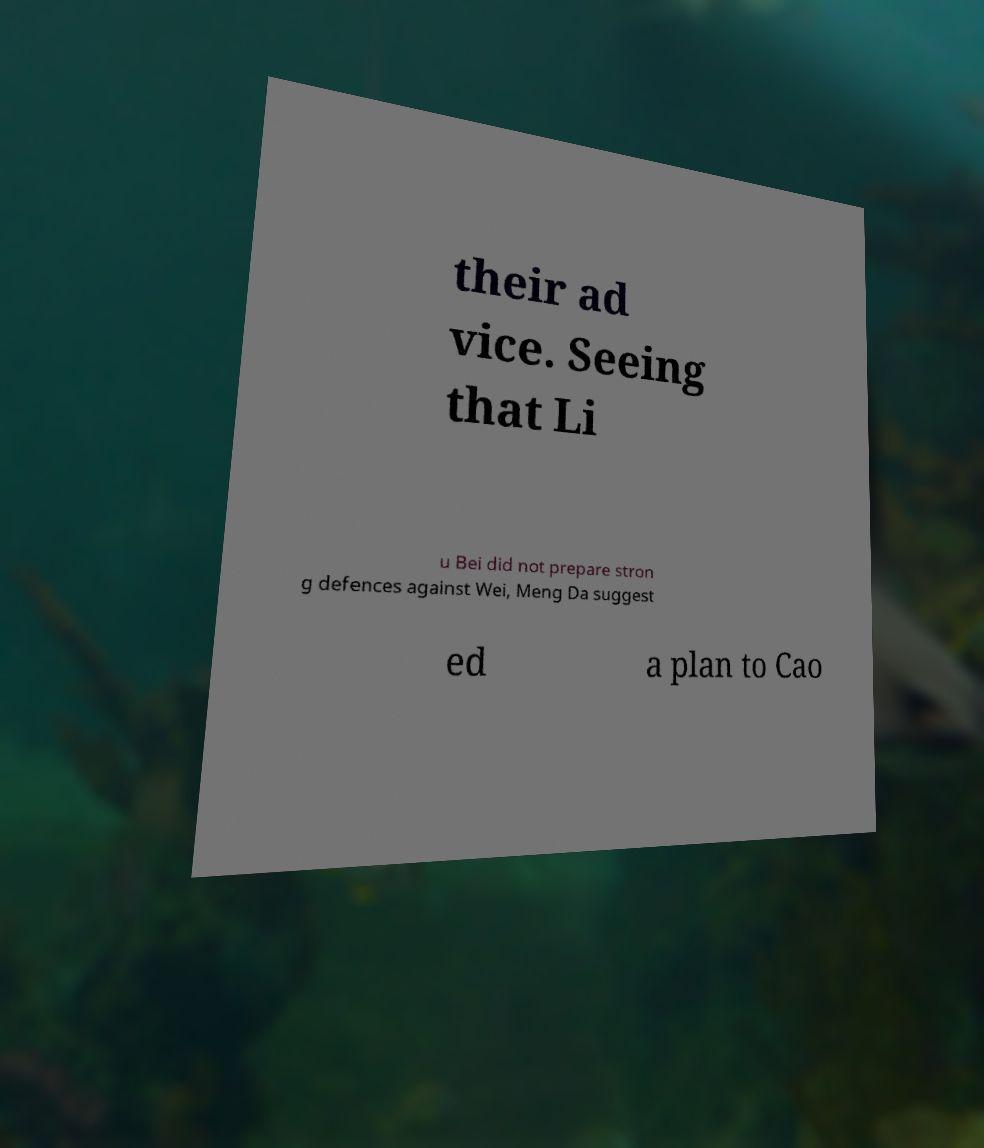For documentation purposes, I need the text within this image transcribed. Could you provide that? their ad vice. Seeing that Li u Bei did not prepare stron g defences against Wei, Meng Da suggest ed a plan to Cao 